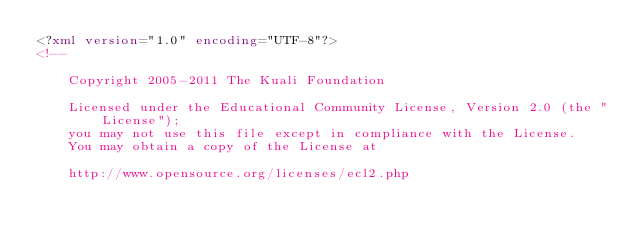Convert code to text. <code><loc_0><loc_0><loc_500><loc_500><_XML_><?xml version="1.0" encoding="UTF-8"?>
<!--

    Copyright 2005-2011 The Kuali Foundation

    Licensed under the Educational Community License, Version 2.0 (the "License");
    you may not use this file except in compliance with the License.
    You may obtain a copy of the License at

    http://www.opensource.org/licenses/ecl2.php
</code> 